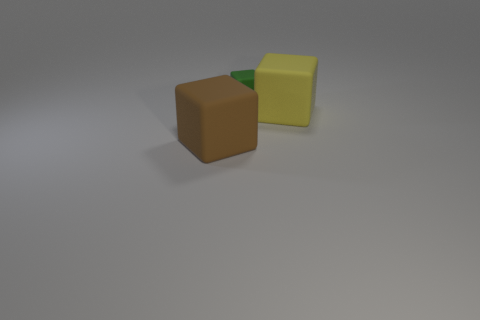Does the brown cube have the same material as the yellow block in front of the tiny green block?
Give a very brief answer. Yes. Is the number of tiny cubes that are left of the tiny rubber thing greater than the number of cubes behind the big yellow object?
Your answer should be compact. No. There is a matte thing that is in front of the yellow matte object that is behind the big brown object; what is its color?
Provide a short and direct response. Brown. What number of blocks are either big brown rubber things or big matte objects?
Your answer should be very brief. 2. How many matte cubes are in front of the yellow rubber block and to the right of the small cube?
Ensure brevity in your answer.  0. The block that is in front of the yellow cube is what color?
Your answer should be compact. Brown. What is the size of the green object that is the same material as the large yellow thing?
Make the answer very short. Small. What number of small matte things are right of the big block behind the big brown rubber block?
Make the answer very short. 0. How many small matte cubes are to the right of the tiny object?
Make the answer very short. 0. What is the color of the big cube in front of the large cube to the right of the block that is behind the large yellow cube?
Make the answer very short. Brown. 